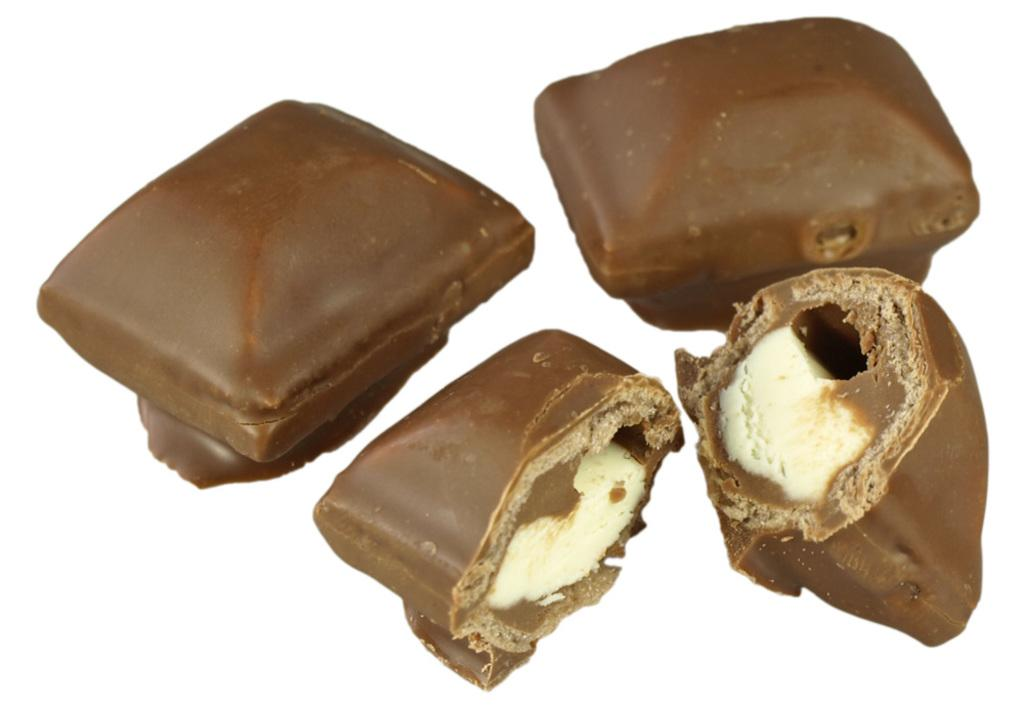What type of food is visible in the image? There are chocolate pieces in the image. What type of boat is shown in the image? There is no boat present in the image; it only features chocolate pieces. What type of truck can be seen transporting the chocolate pieces in the image? There is no truck present in the image; it only features chocolate pieces. 